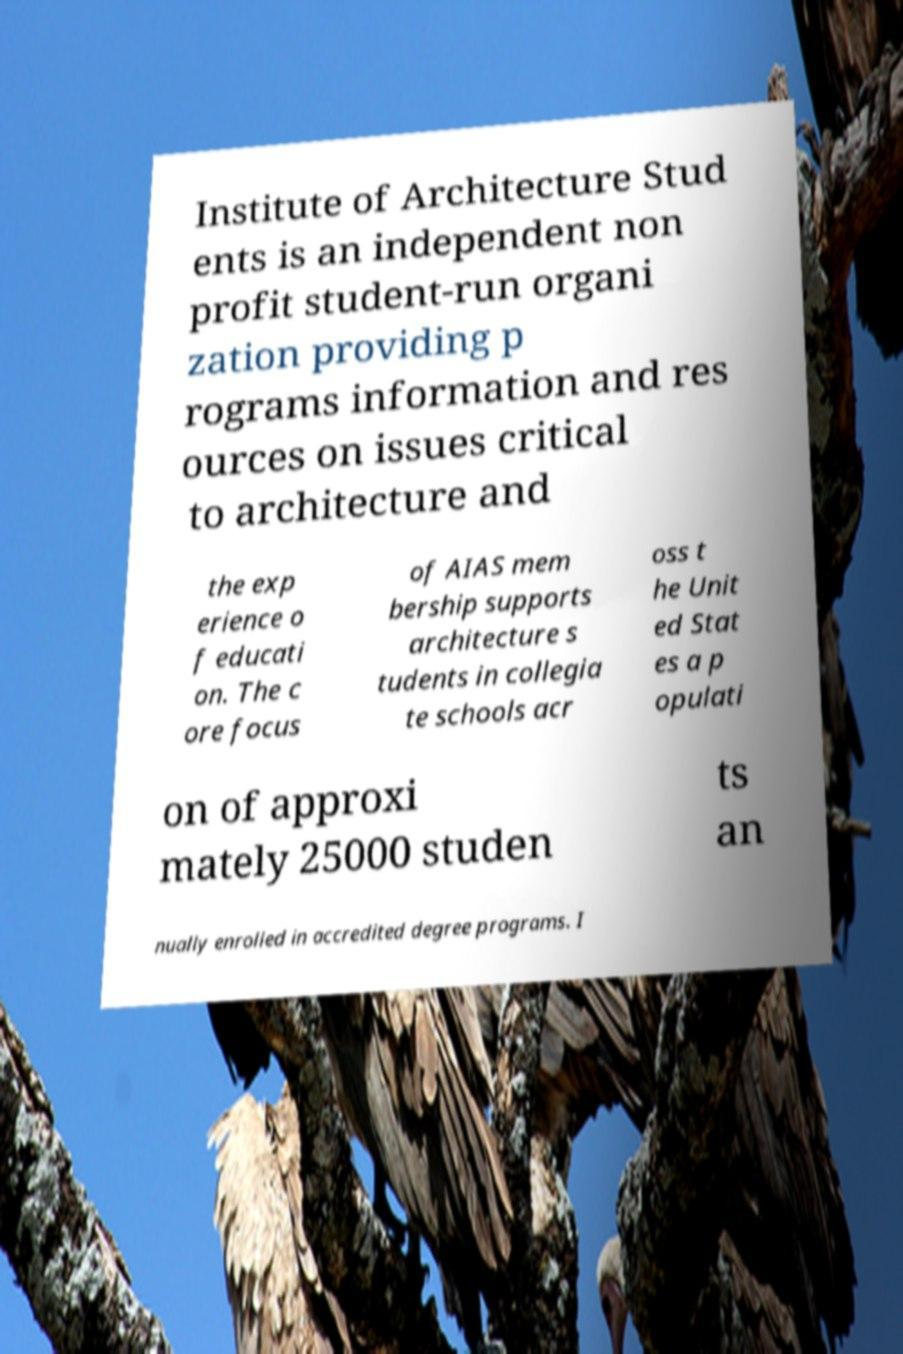Could you extract and type out the text from this image? Institute of Architecture Stud ents is an independent non profit student-run organi zation providing p rograms information and res ources on issues critical to architecture and the exp erience o f educati on. The c ore focus of AIAS mem bership supports architecture s tudents in collegia te schools acr oss t he Unit ed Stat es a p opulati on of approxi mately 25000 studen ts an nually enrolled in accredited degree programs. I 